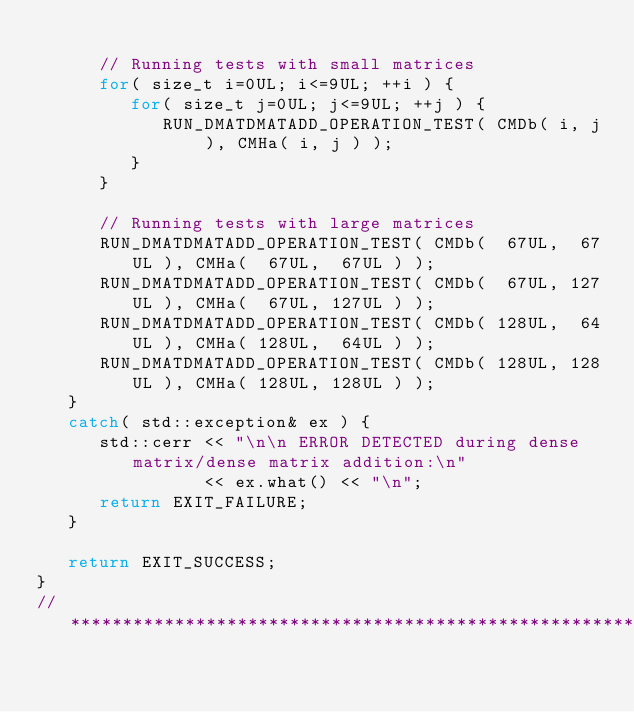Convert code to text. <code><loc_0><loc_0><loc_500><loc_500><_C++_>
      // Running tests with small matrices
      for( size_t i=0UL; i<=9UL; ++i ) {
         for( size_t j=0UL; j<=9UL; ++j ) {
            RUN_DMATDMATADD_OPERATION_TEST( CMDb( i, j ), CMHa( i, j ) );
         }
      }

      // Running tests with large matrices
      RUN_DMATDMATADD_OPERATION_TEST( CMDb(  67UL,  67UL ), CMHa(  67UL,  67UL ) );
      RUN_DMATDMATADD_OPERATION_TEST( CMDb(  67UL, 127UL ), CMHa(  67UL, 127UL ) );
      RUN_DMATDMATADD_OPERATION_TEST( CMDb( 128UL,  64UL ), CMHa( 128UL,  64UL ) );
      RUN_DMATDMATADD_OPERATION_TEST( CMDb( 128UL, 128UL ), CMHa( 128UL, 128UL ) );
   }
   catch( std::exception& ex ) {
      std::cerr << "\n\n ERROR DETECTED during dense matrix/dense matrix addition:\n"
                << ex.what() << "\n";
      return EXIT_FAILURE;
   }

   return EXIT_SUCCESS;
}
//*************************************************************************************************
</code> 